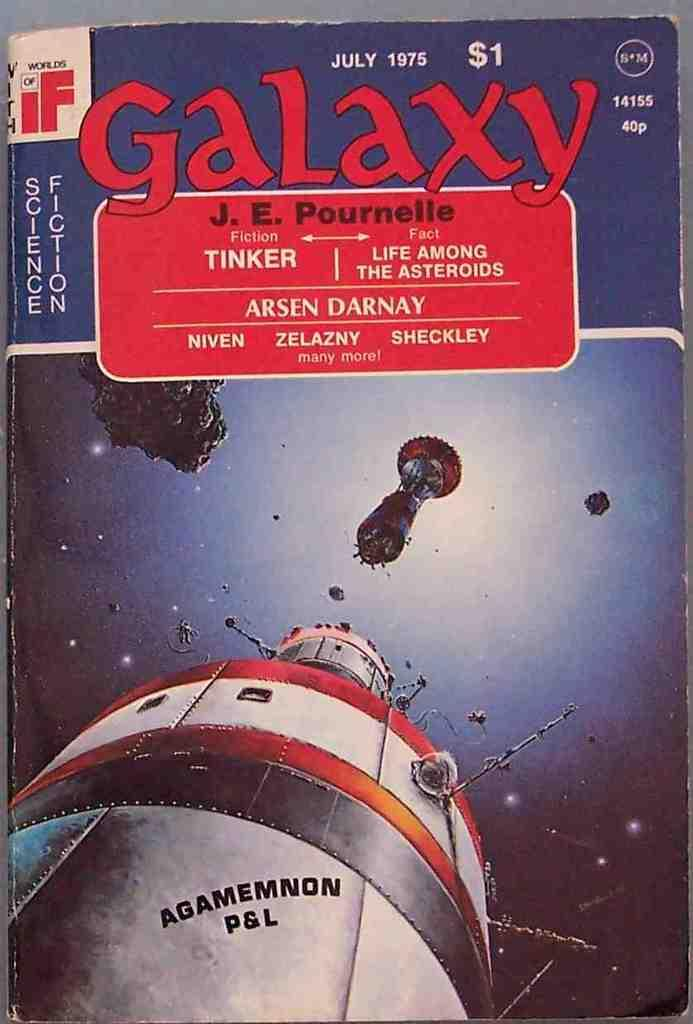Provide a one-sentence caption for the provided image. The july 1975 cover of Galaxy features the spaceship Agamemnon P&L. 